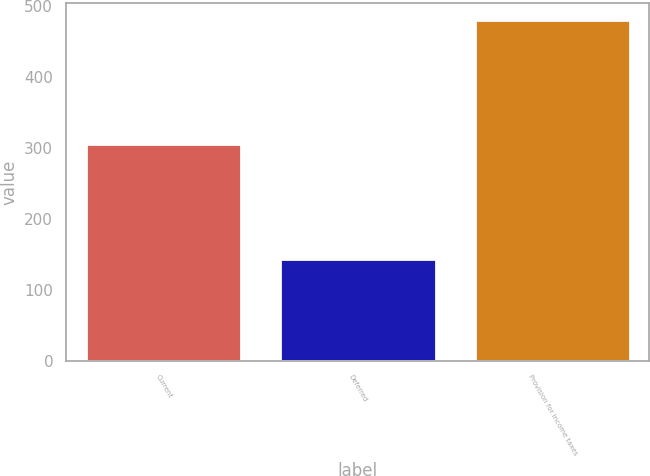Convert chart. <chart><loc_0><loc_0><loc_500><loc_500><bar_chart><fcel>Current<fcel>Deferred<fcel>Provision for income taxes<nl><fcel>305<fcel>144<fcel>480<nl></chart> 